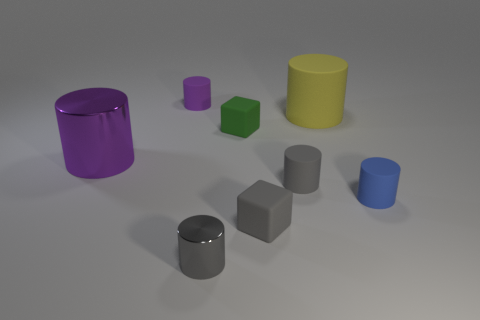Subtract 1 cylinders. How many cylinders are left? 5 Subtract all yellow cylinders. How many cylinders are left? 5 Subtract all tiny metal cylinders. How many cylinders are left? 5 Subtract all yellow cylinders. Subtract all red cubes. How many cylinders are left? 5 Add 1 small gray objects. How many objects exist? 9 Subtract all cylinders. How many objects are left? 2 Add 6 yellow rubber objects. How many yellow rubber objects exist? 7 Subtract 1 gray cubes. How many objects are left? 7 Subtract all tiny green blocks. Subtract all tiny gray cylinders. How many objects are left? 5 Add 6 small gray rubber cylinders. How many small gray rubber cylinders are left? 7 